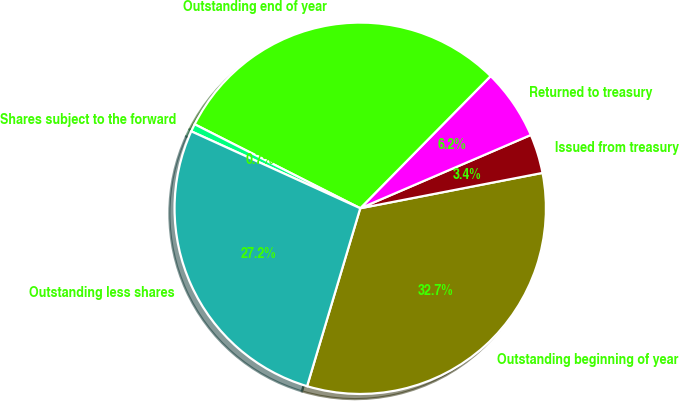Convert chart. <chart><loc_0><loc_0><loc_500><loc_500><pie_chart><fcel>Outstanding beginning of year<fcel>Issued from treasury<fcel>Returned to treasury<fcel>Outstanding end of year<fcel>Shares subject to the forward<fcel>Outstanding less shares<nl><fcel>32.67%<fcel>3.41%<fcel>6.15%<fcel>29.92%<fcel>0.67%<fcel>27.18%<nl></chart> 